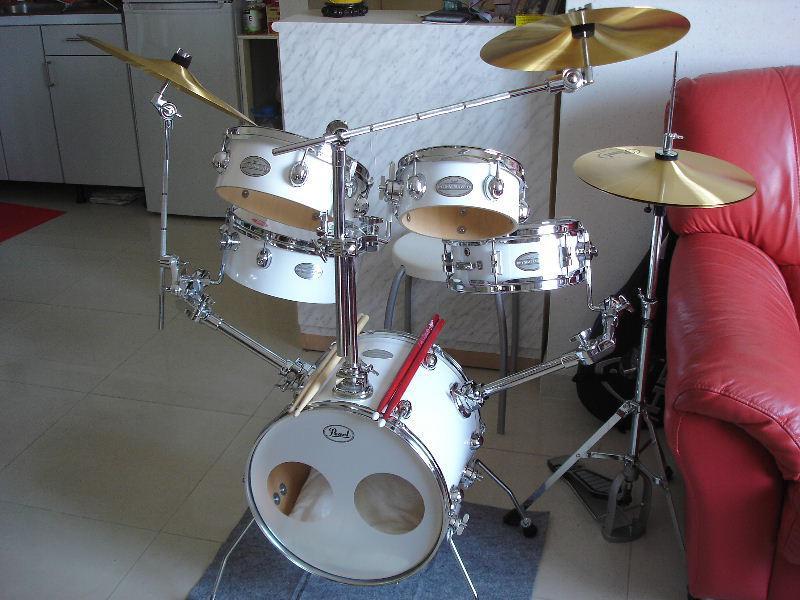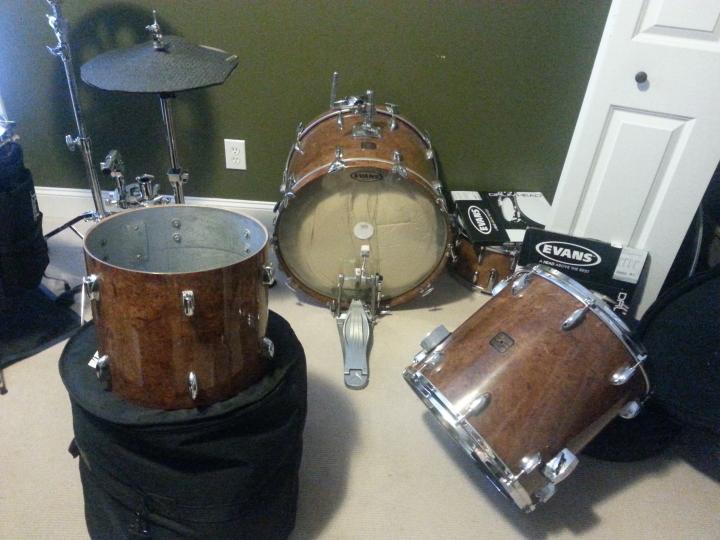The first image is the image on the left, the second image is the image on the right. Considering the images on both sides, is "The image on the right shows a single person playing a drum kit with drumsticks." valid? Answer yes or no. No. The first image is the image on the left, the second image is the image on the right. For the images shown, is this caption "An image includes at least one person wearing a type of harness and standing behind a set of connected drums with four larger drums in front of two smaller ones." true? Answer yes or no. No. 